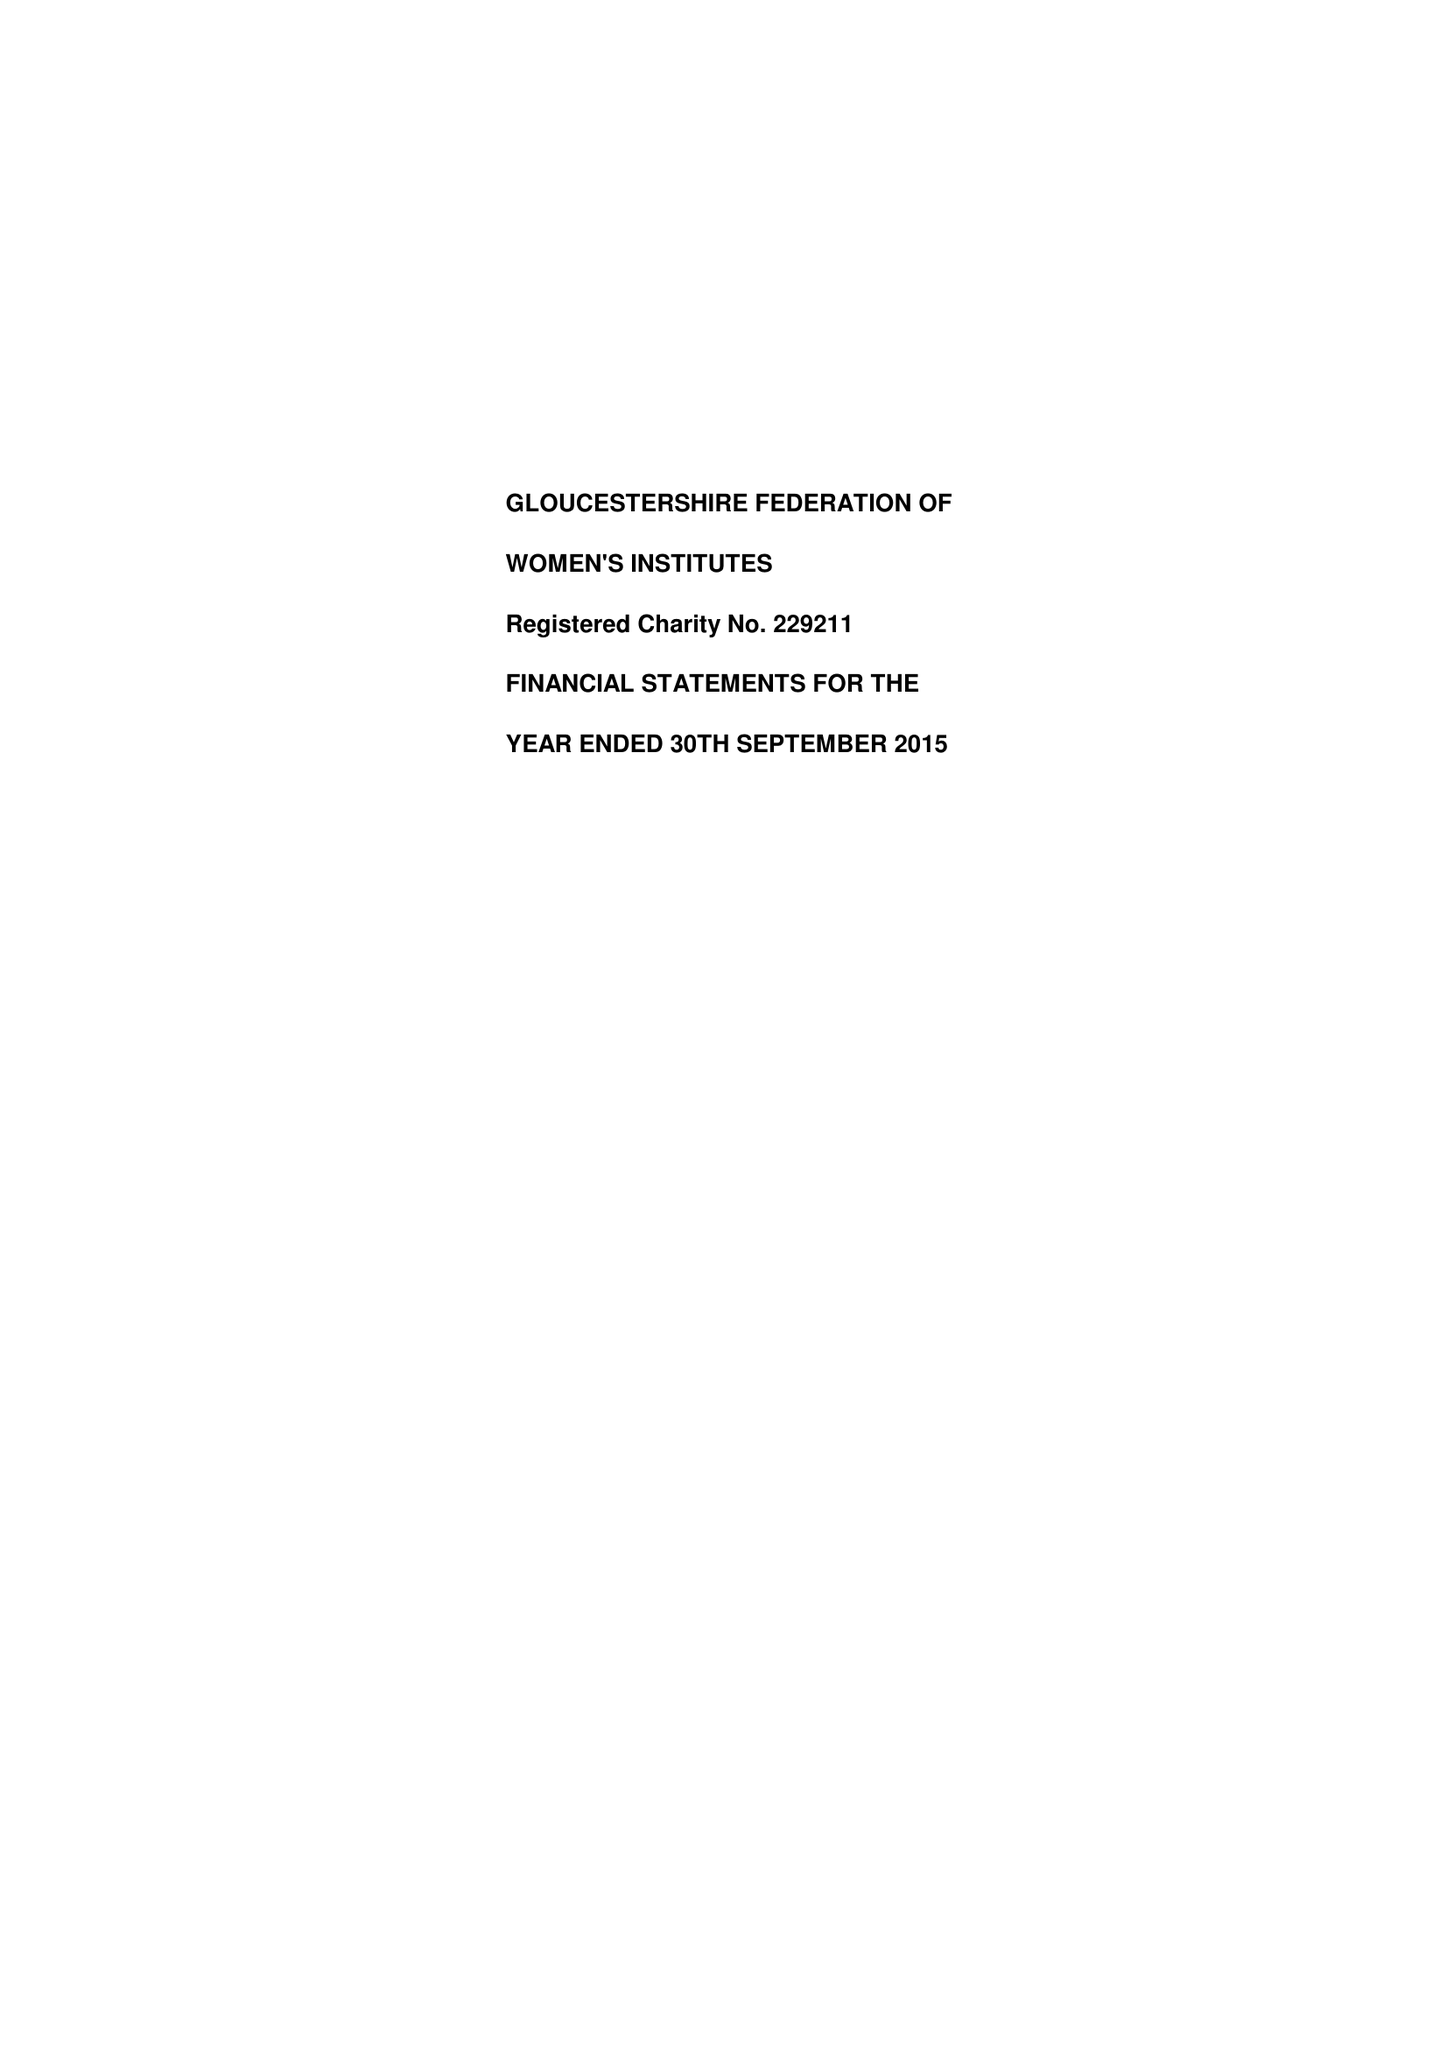What is the value for the charity_name?
Answer the question using a single word or phrase. Gloucestershire Federation Of Women's Institutes 